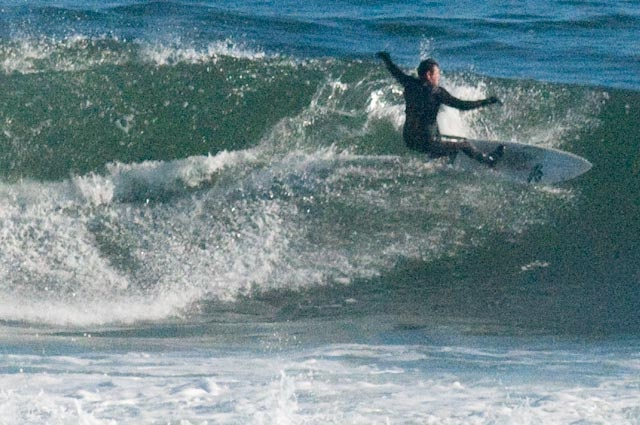Describe the objects in this image and their specific colors. I can see people in gray, navy, blue, and darkblue tones and surfboard in gray and blue tones in this image. 